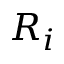Convert formula to latex. <formula><loc_0><loc_0><loc_500><loc_500>R _ { i }</formula> 